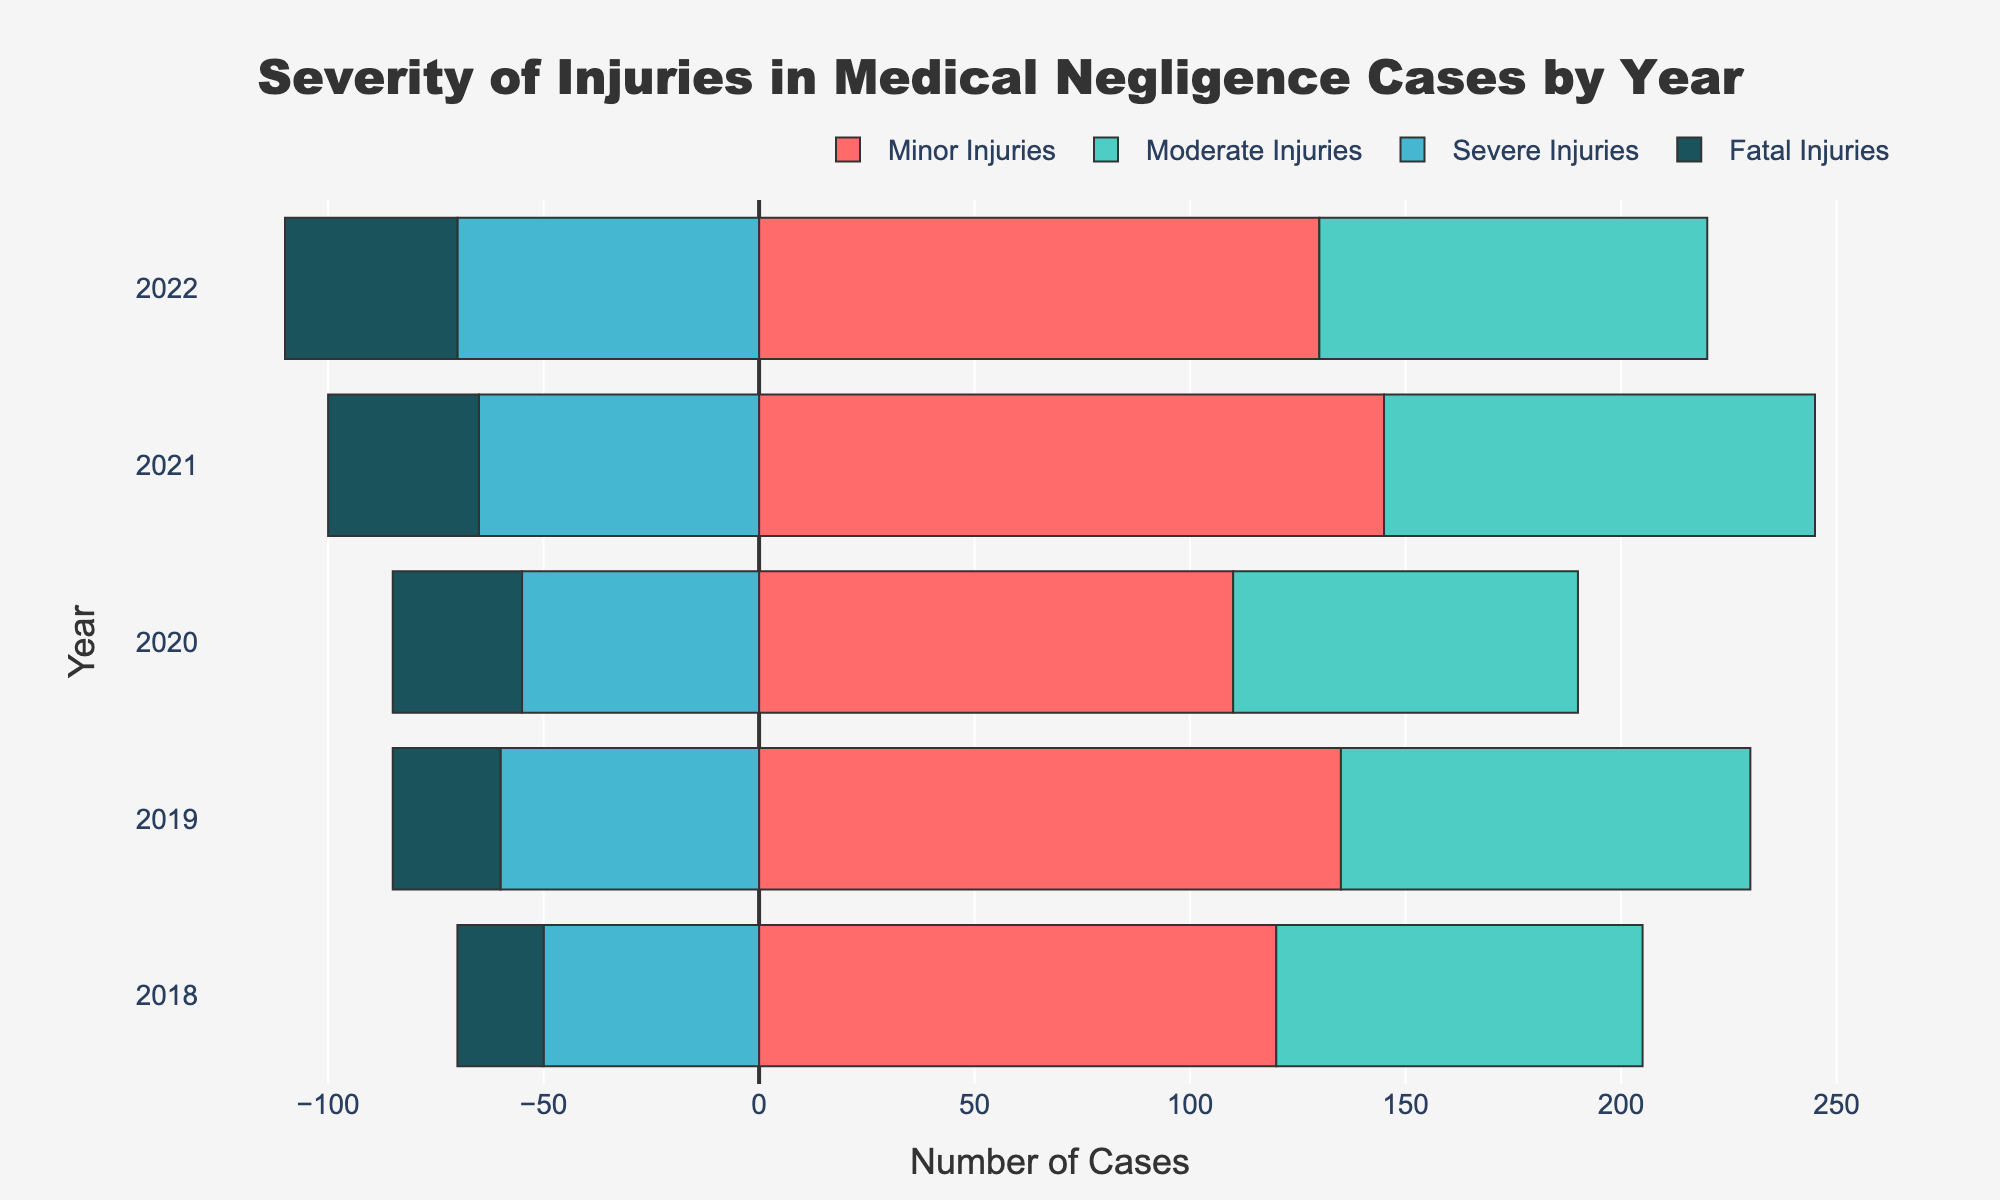What year had the highest number of severe injuries? Look at the severe injuries bars and identify the year with the longest bar. The longest severe injuries bar is in 2022.
Answer: 2022 Which year had more minor injuries, 2019 or 2022? Compare the length of the minor injuries bars for 2019 and 2022. The minor injuries bar is longer in 2019.
Answer: 2019 What is the total number of cases with moderate injuries in 2021 and 2022 combined? Add the moderate injuries values for 2021 and 2022. The values are 100 (2021) and 90 (2022), totaling 190.
Answer: 190 How did the total number of fatal injuries change between 2018 and 2022? Subtract the fatal injuries value in 2018 from that in 2022. The values are 40 (2022) and 20 (2018), so 40 - 20 = 20, indicating an increase of 20 cases.
Answer: Increased by 20 Which injury category had the least number of cases in 2018? Identify the bar with the smallest length in 2018. The shortest bar is the fatal injuries bar.
Answer: Fatal Injuries In 2020, were there more moderate or severe injuries? Compare the lengths of the moderate and severe injuries bars in 2020. The moderate injuries bar is longer.
Answer: Moderate Injuries What is the average number of minor injuries from 2018 to 2022? Add the minor injuries values (120, 135, 110, 145, 130) and divide by 5. The sum is 640, so 640 / 5 = 128.
Answer: 128 Which year had the highest total number of reported injuries (all categories combined)? Sum the values of all categories for each year and find the maximum. 2018 sums to (120+85+50+20)=275, 2019 to (135+95+60+25)=315, 2020 to (110+80+55+30)=275, 2021 to (145+100+65+35)=345, and 2022 to (130+90+70+40)=330. The highest total is in 2021 with 345.
Answer: 2021 Did the number of cases with fatal injuries consistently increase each year from 2018 to 2022? Check if each year's fatal injuries value is greater than the previous year's. The values are 20 (2018), 25 (2019), 30 (2020), 35 (2021), 40 (2022). Each year's value is greater than the previous year's.
Answer: Yes 